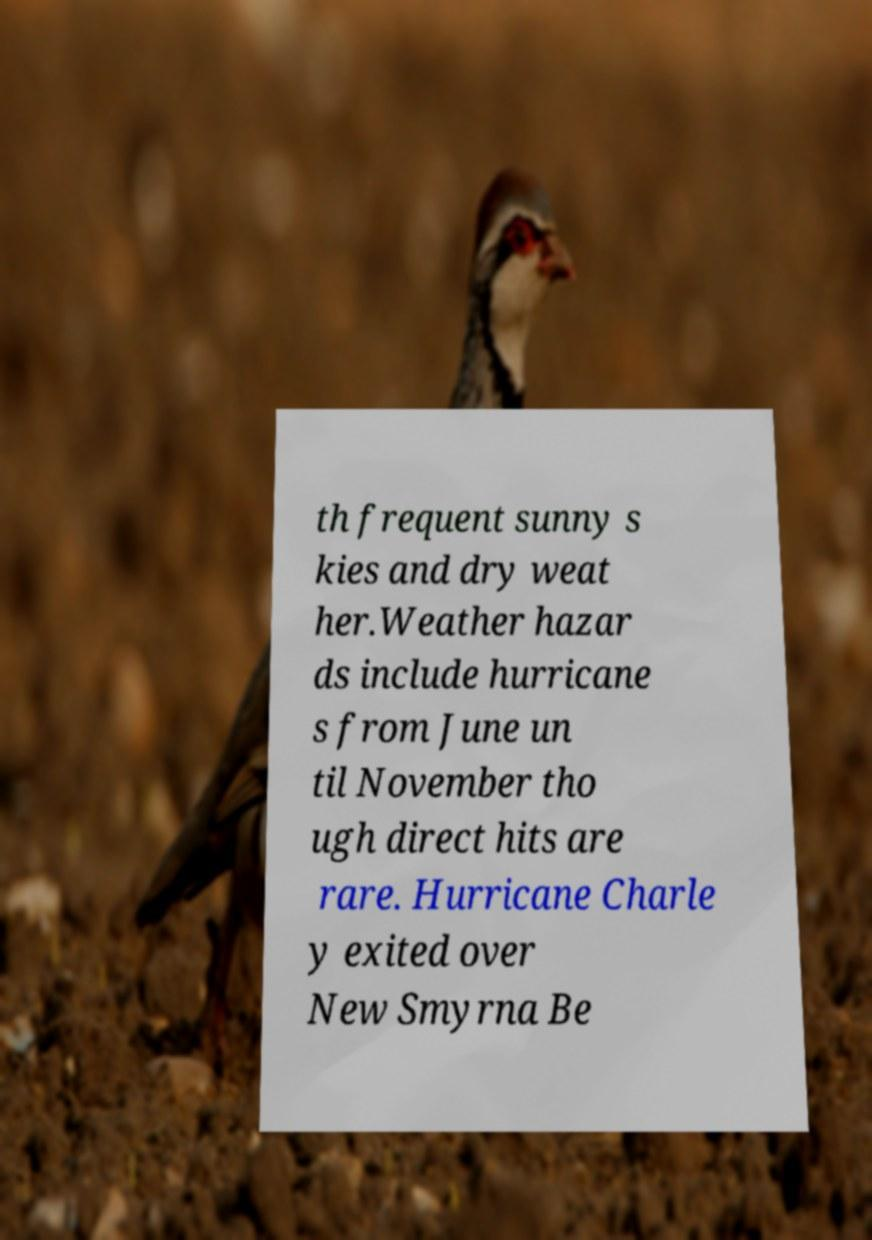Can you accurately transcribe the text from the provided image for me? th frequent sunny s kies and dry weat her.Weather hazar ds include hurricane s from June un til November tho ugh direct hits are rare. Hurricane Charle y exited over New Smyrna Be 